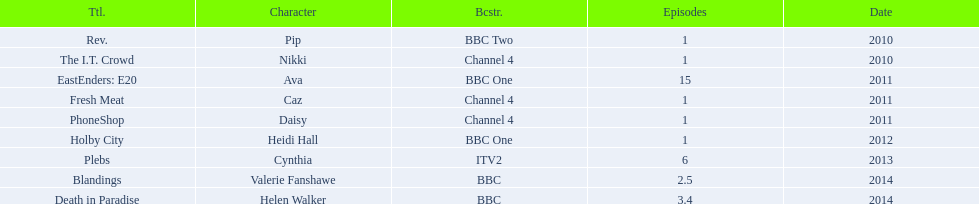Which characters were featured in more then one episode? Ava, Cynthia, Valerie Fanshawe, Helen Walker. Which of these were not in 2014? Ava, Cynthia. Which one of those was not on a bbc broadcaster? Cynthia. 